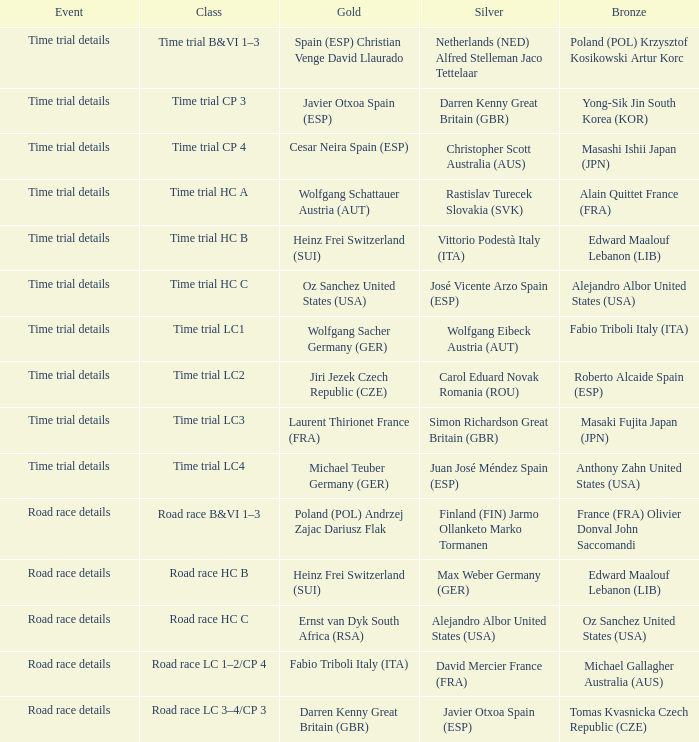What is the event when gold is darren kenny great britain (gbr)? Road race details. 